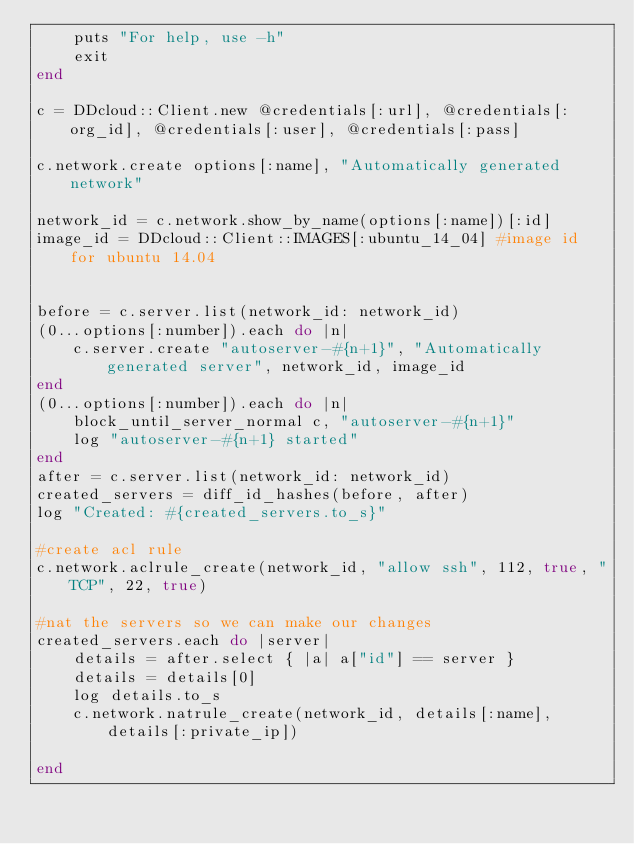Convert code to text. <code><loc_0><loc_0><loc_500><loc_500><_Ruby_>	puts "For help, use -h"
	exit
end

c = DDcloud::Client.new @credentials[:url], @credentials[:org_id], @credentials[:user], @credentials[:pass]

c.network.create options[:name], "Automatically generated network"

network_id = c.network.show_by_name(options[:name])[:id]
image_id = DDcloud::Client::IMAGES[:ubuntu_14_04] #image id for ubuntu 14.04


before = c.server.list(network_id: network_id)
(0...options[:number]).each do |n|
	c.server.create "autoserver-#{n+1}", "Automatically generated server", network_id, image_id
end
(0...options[:number]).each do |n|
	block_until_server_normal c, "autoserver-#{n+1}"
	log "autoserver-#{n+1} started"
end
after = c.server.list(network_id: network_id)
created_servers = diff_id_hashes(before, after)
log "Created: #{created_servers.to_s}"

#create acl rule
c.network.aclrule_create(network_id, "allow ssh", 112, true, "TCP", 22, true)

#nat the servers so we can make our changes
created_servers.each do |server|
	details = after.select { |a| a["id"] == server }
	details = details[0]
	log details.to_s
	c.network.natrule_create(network_id, details[:name], details[:private_ip])

end
</code> 